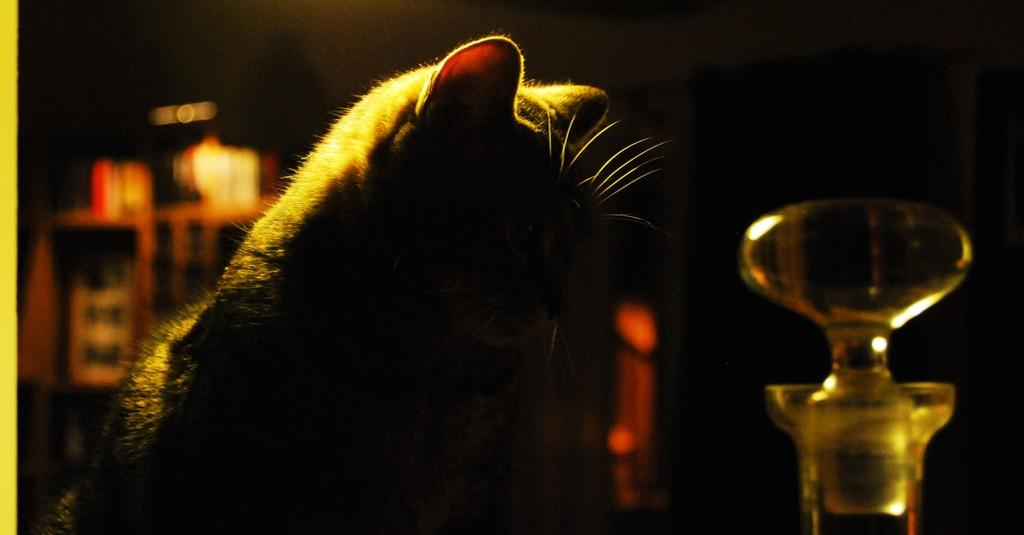What type of animal is in the image? There is a cat in the image. What object can be seen on the right side of the image? There is a bottle on the right side of the image. How would you describe the lighting in the image? The background of the image is dark. What type of debt is the cat discussing with its grandfather in the image? There is no mention of debt or a grandfather in the image; it features a cat and a bottle. What is the cat's fear in the image? There is no indication of fear in the image; the cat is simply present in the scene. 